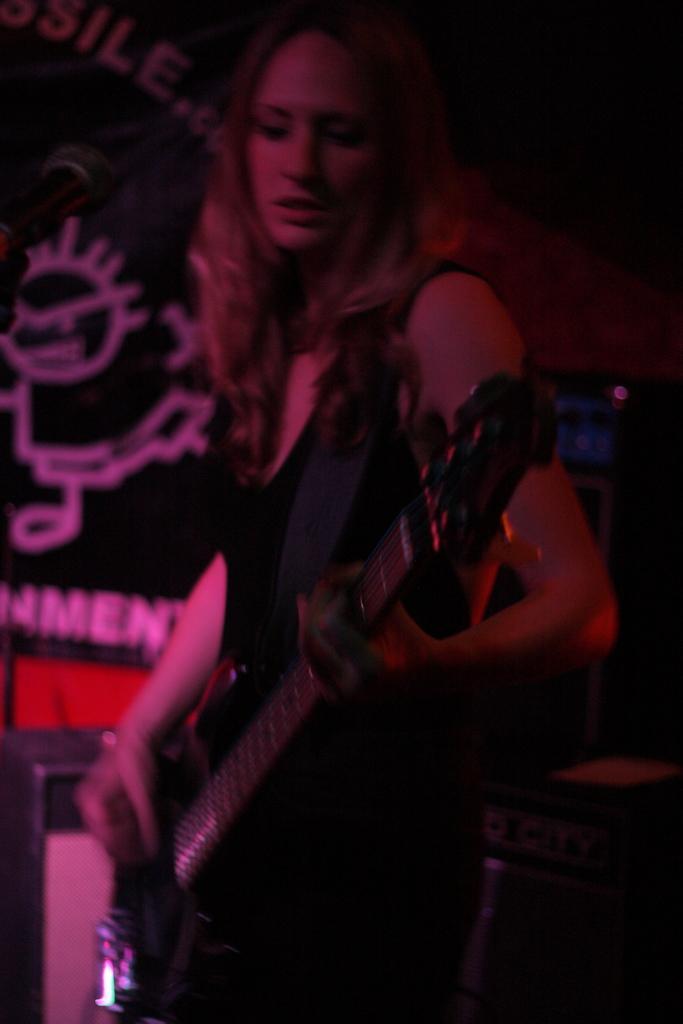Describe this image in one or two sentences. Here we can see a woman holding a guitar, probably playing the guitar 